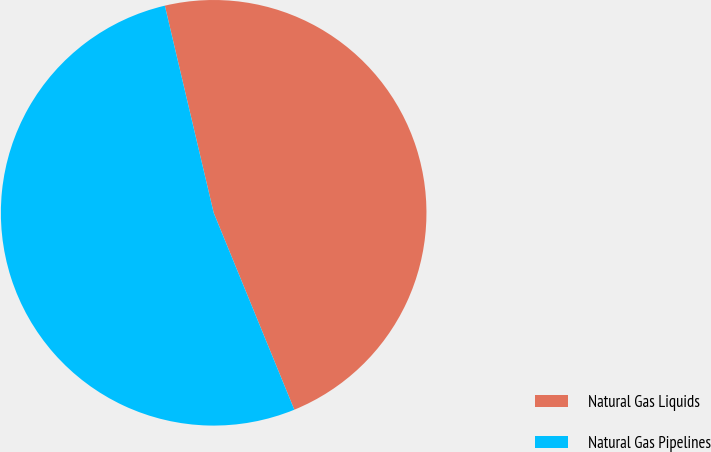Convert chart to OTSL. <chart><loc_0><loc_0><loc_500><loc_500><pie_chart><fcel>Natural Gas Liquids<fcel>Natural Gas Pipelines<nl><fcel>47.5%<fcel>52.5%<nl></chart> 